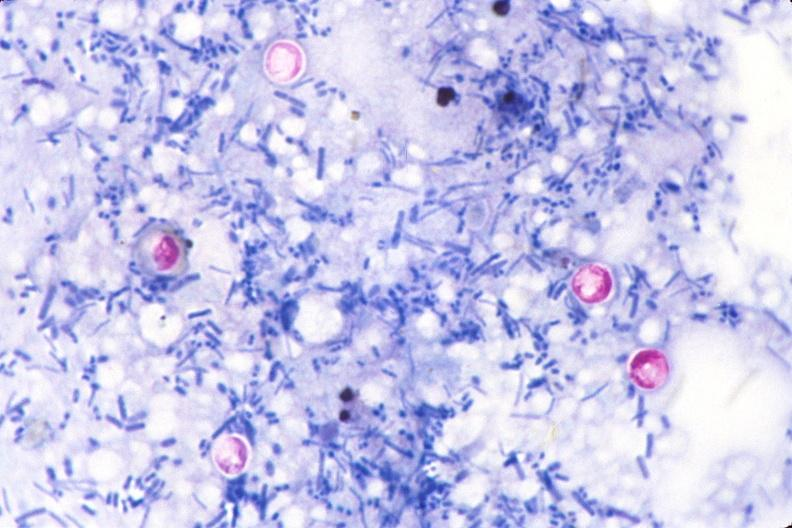s fibrotic lesion present?
Answer the question using a single word or phrase. No 